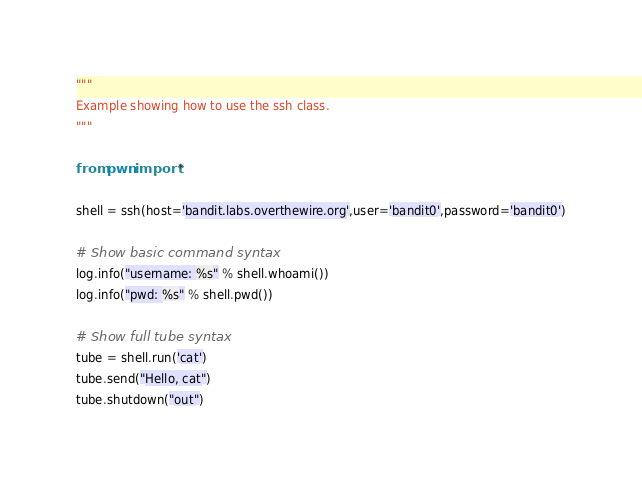Convert code to text. <code><loc_0><loc_0><loc_500><loc_500><_Python_>"""
Example showing how to use the ssh class.
"""

from pwn import *

shell = ssh(host='bandit.labs.overthewire.org',user='bandit0',password='bandit0')

# Show basic command syntax
log.info("username: %s" % shell.whoami())
log.info("pwd: %s" % shell.pwd())

# Show full tube syntax
tube = shell.run('cat')
tube.send("Hello, cat")
tube.shutdown("out")</code> 